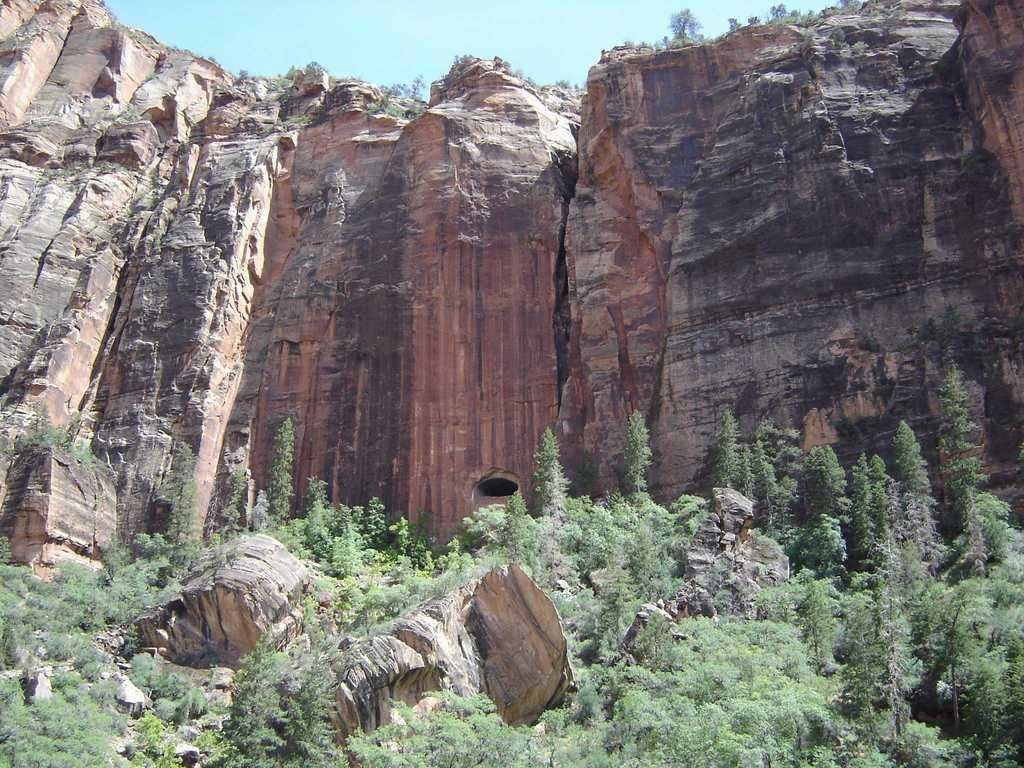What is the possible location from where the image was taken? The image might be taken from outside of the city. What type of vegetation can be seen in the image? There are trees in the image. What other natural elements are present in the image? There are rocks and stones in the image. What is visible at the top of the image? The sky is visible at the top of the image. What type of ground cover is present at the bottom of the image? Grass is present at the bottom of the image. Are there any stones mixed with the grass at the bottom of the image? Yes, there are stones among the grass at the bottom of the image. Can you see a squirrel holding a quiver in the image? No, there is no squirrel or quiver present in the image. Is there a lawyer standing among the trees in the image? No, there is no lawyer present in the image. 